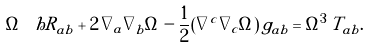<formula> <loc_0><loc_0><loc_500><loc_500>\Omega \, \ h R _ { a b } + 2 \, \nabla _ { a } \nabla _ { b } \Omega - \frac { 1 } { 2 } ( \nabla ^ { c } \nabla _ { c } \Omega ) \, g _ { a b } = \Omega ^ { 3 } \, T _ { a b } .</formula> 